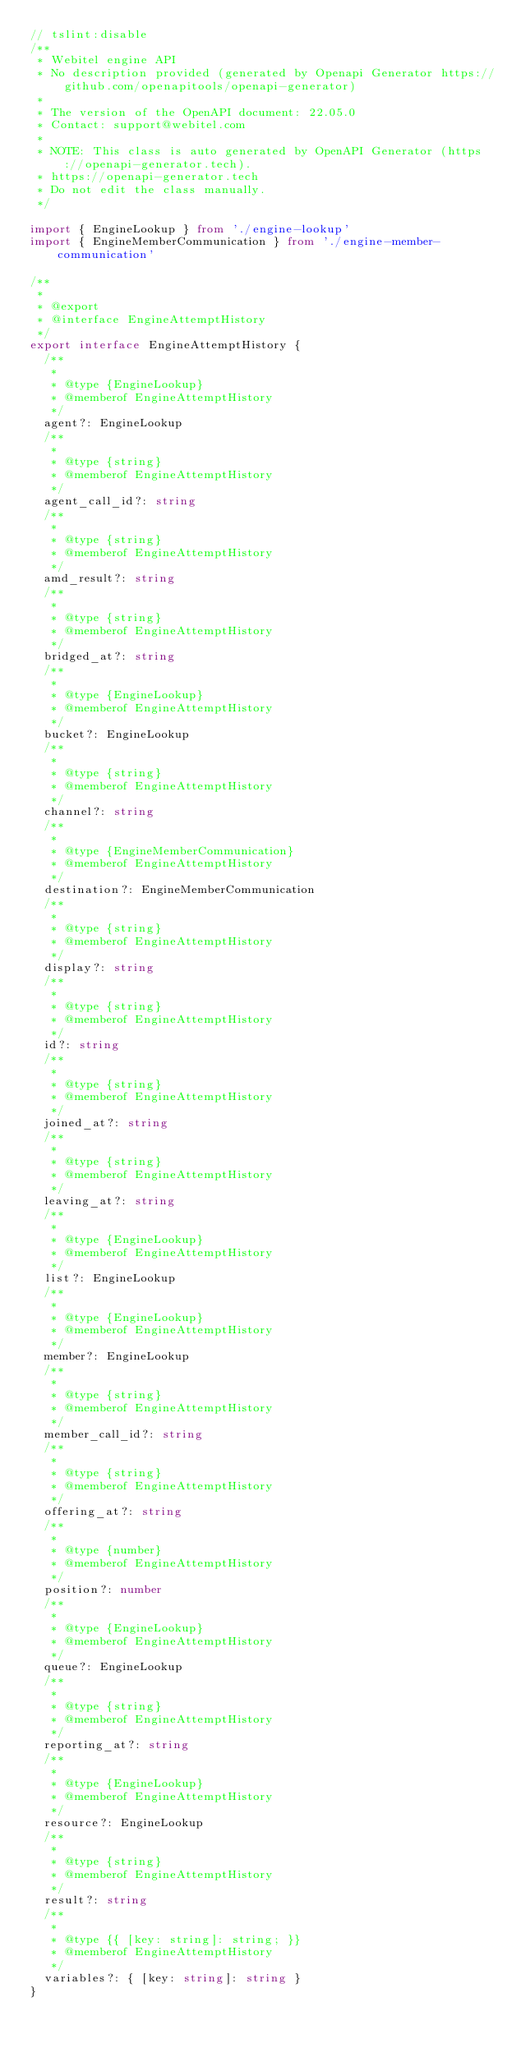Convert code to text. <code><loc_0><loc_0><loc_500><loc_500><_TypeScript_>// tslint:disable
/**
 * Webitel engine API
 * No description provided (generated by Openapi Generator https://github.com/openapitools/openapi-generator)
 *
 * The version of the OpenAPI document: 22.05.0
 * Contact: support@webitel.com
 *
 * NOTE: This class is auto generated by OpenAPI Generator (https://openapi-generator.tech).
 * https://openapi-generator.tech
 * Do not edit the class manually.
 */

import { EngineLookup } from './engine-lookup'
import { EngineMemberCommunication } from './engine-member-communication'

/**
 *
 * @export
 * @interface EngineAttemptHistory
 */
export interface EngineAttemptHistory {
  /**
   *
   * @type {EngineLookup}
   * @memberof EngineAttemptHistory
   */
  agent?: EngineLookup
  /**
   *
   * @type {string}
   * @memberof EngineAttemptHistory
   */
  agent_call_id?: string
  /**
   *
   * @type {string}
   * @memberof EngineAttemptHistory
   */
  amd_result?: string
  /**
   *
   * @type {string}
   * @memberof EngineAttemptHistory
   */
  bridged_at?: string
  /**
   *
   * @type {EngineLookup}
   * @memberof EngineAttemptHistory
   */
  bucket?: EngineLookup
  /**
   *
   * @type {string}
   * @memberof EngineAttemptHistory
   */
  channel?: string
  /**
   *
   * @type {EngineMemberCommunication}
   * @memberof EngineAttemptHistory
   */
  destination?: EngineMemberCommunication
  /**
   *
   * @type {string}
   * @memberof EngineAttemptHistory
   */
  display?: string
  /**
   *
   * @type {string}
   * @memberof EngineAttemptHistory
   */
  id?: string
  /**
   *
   * @type {string}
   * @memberof EngineAttemptHistory
   */
  joined_at?: string
  /**
   *
   * @type {string}
   * @memberof EngineAttemptHistory
   */
  leaving_at?: string
  /**
   *
   * @type {EngineLookup}
   * @memberof EngineAttemptHistory
   */
  list?: EngineLookup
  /**
   *
   * @type {EngineLookup}
   * @memberof EngineAttemptHistory
   */
  member?: EngineLookup
  /**
   *
   * @type {string}
   * @memberof EngineAttemptHistory
   */
  member_call_id?: string
  /**
   *
   * @type {string}
   * @memberof EngineAttemptHistory
   */
  offering_at?: string
  /**
   *
   * @type {number}
   * @memberof EngineAttemptHistory
   */
  position?: number
  /**
   *
   * @type {EngineLookup}
   * @memberof EngineAttemptHistory
   */
  queue?: EngineLookup
  /**
   *
   * @type {string}
   * @memberof EngineAttemptHistory
   */
  reporting_at?: string
  /**
   *
   * @type {EngineLookup}
   * @memberof EngineAttemptHistory
   */
  resource?: EngineLookup
  /**
   *
   * @type {string}
   * @memberof EngineAttemptHistory
   */
  result?: string
  /**
   *
   * @type {{ [key: string]: string; }}
   * @memberof EngineAttemptHistory
   */
  variables?: { [key: string]: string }
}
</code> 